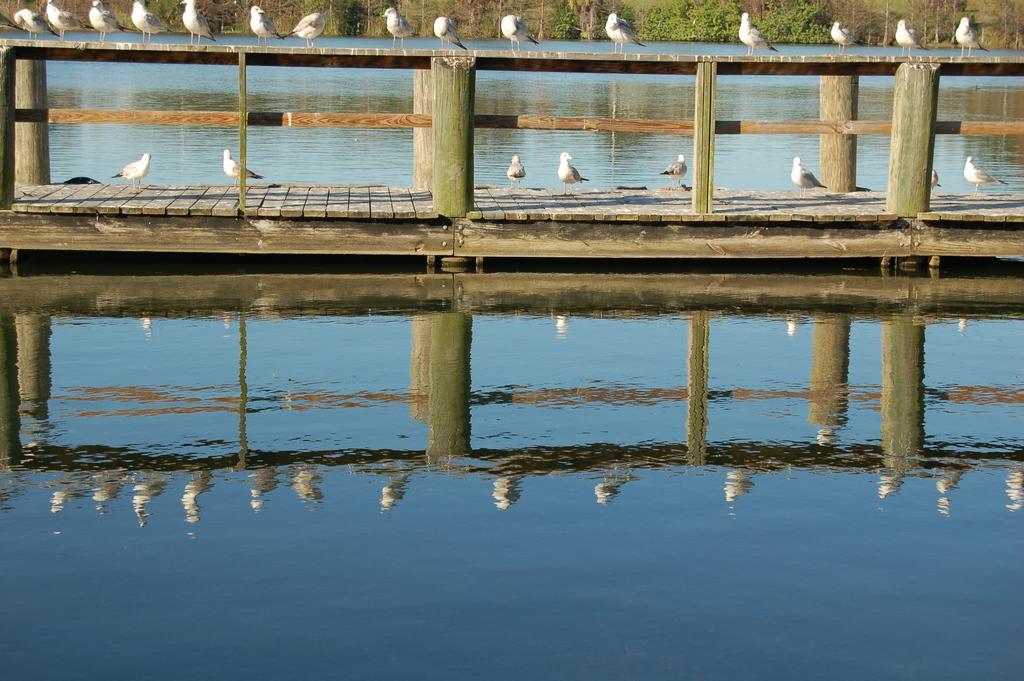How would you summarize this image in a sentence or two? In the image there are many birds standing on bridge over a lake, in the background there are trees. 